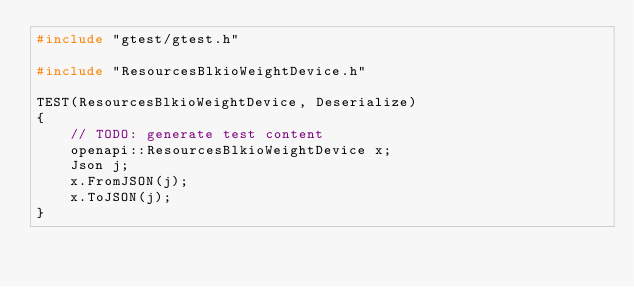<code> <loc_0><loc_0><loc_500><loc_500><_C++_>#include "gtest/gtest.h"

#include "ResourcesBlkioWeightDevice.h"

TEST(ResourcesBlkioWeightDevice, Deserialize)
{
    // TODO: generate test content
    openapi::ResourcesBlkioWeightDevice x;
    Json j;
    x.FromJSON(j);
    x.ToJSON(j);
}</code> 